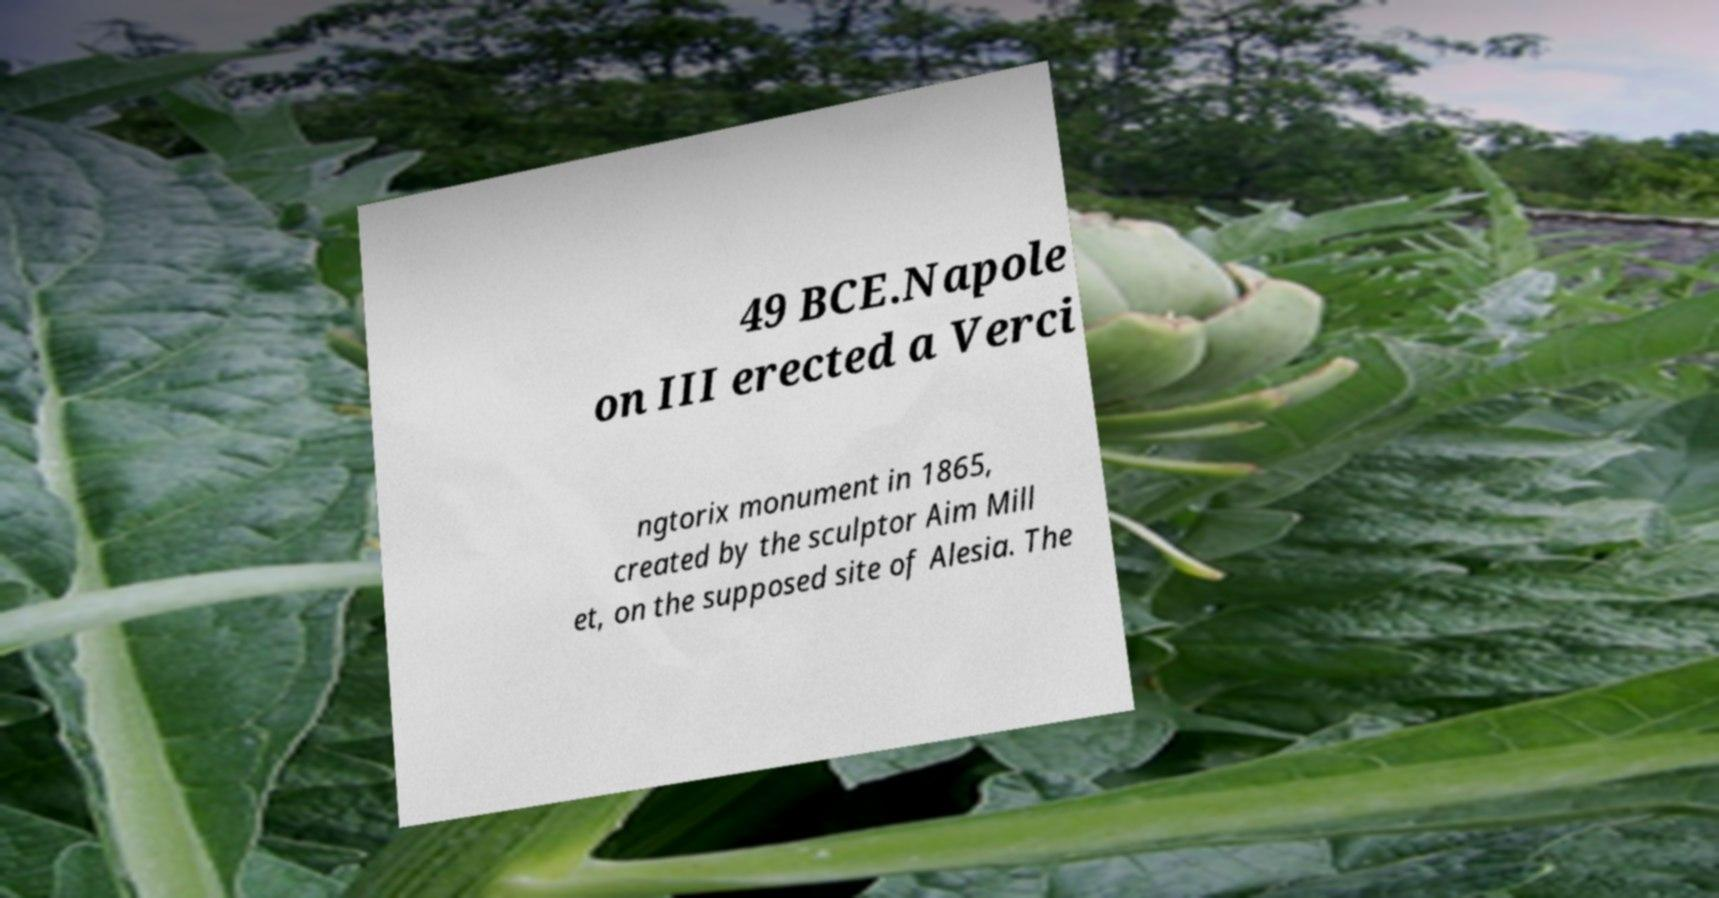Please identify and transcribe the text found in this image. 49 BCE.Napole on III erected a Verci ngtorix monument in 1865, created by the sculptor Aim Mill et, on the supposed site of Alesia. The 